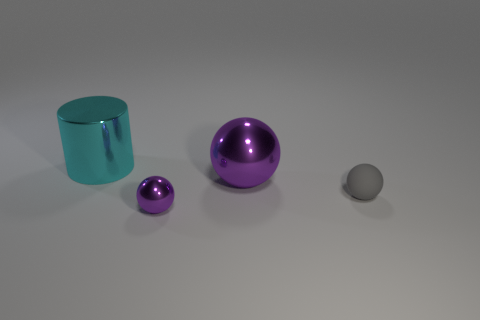There is a thing left of the small sphere that is on the left side of the big object that is in front of the large cyan shiny thing; how big is it?
Keep it short and to the point. Large. Is the shape of the tiny purple metallic object the same as the purple object that is behind the small gray thing?
Provide a short and direct response. Yes. What is the size of the cyan thing that is the same material as the tiny purple thing?
Keep it short and to the point. Large. Is there any other thing that has the same color as the tiny matte sphere?
Offer a terse response. No. There is a small sphere right of the small thing in front of the sphere to the right of the big purple metallic ball; what is its material?
Keep it short and to the point. Rubber. What number of metal things are small purple things or big cyan objects?
Provide a short and direct response. 2. Is the color of the metal cylinder the same as the matte sphere?
Provide a short and direct response. No. Is there any other thing that is made of the same material as the large purple ball?
Offer a very short reply. Yes. What number of things are yellow objects or metallic spheres that are in front of the gray ball?
Give a very brief answer. 1. There is a metallic object that is in front of the rubber sphere; is its size the same as the big purple object?
Offer a terse response. No. 